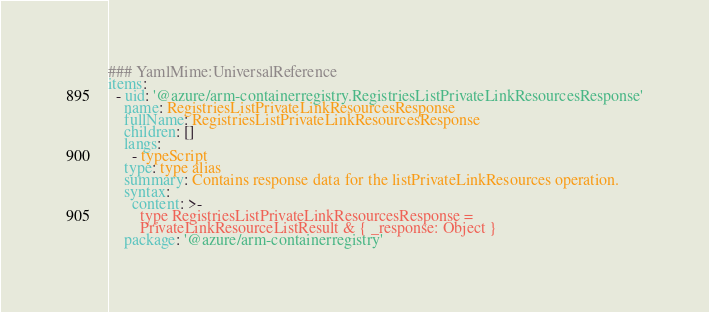<code> <loc_0><loc_0><loc_500><loc_500><_YAML_>### YamlMime:UniversalReference
items:
  - uid: '@azure/arm-containerregistry.RegistriesListPrivateLinkResourcesResponse'
    name: RegistriesListPrivateLinkResourcesResponse
    fullName: RegistriesListPrivateLinkResourcesResponse
    children: []
    langs:
      - typeScript
    type: type alias
    summary: Contains response data for the listPrivateLinkResources operation.
    syntax:
      content: >-
        type RegistriesListPrivateLinkResourcesResponse =
        PrivateLinkResourceListResult & { _response: Object }
    package: '@azure/arm-containerregistry'
</code> 